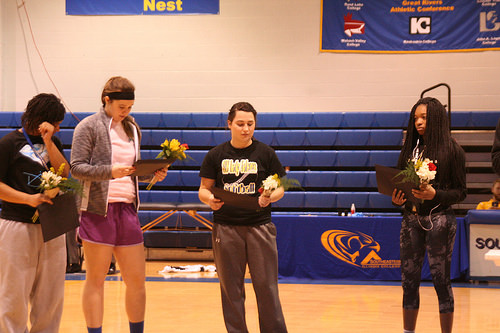<image>
Can you confirm if the flower is in the gym? Yes. The flower is contained within or inside the gym, showing a containment relationship. 